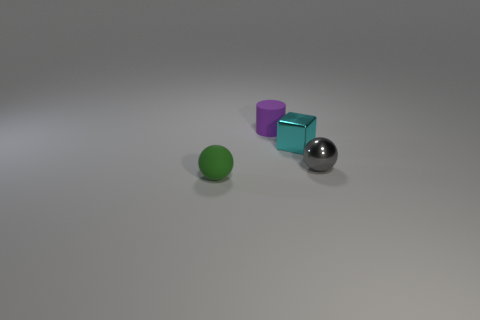Add 1 tiny rubber things. How many objects exist? 5 Subtract all blocks. How many objects are left? 3 Add 4 tiny green spheres. How many tiny green spheres are left? 5 Add 4 tiny cyan rubber things. How many tiny cyan rubber things exist? 4 Subtract 0 blue spheres. How many objects are left? 4 Subtract all brown metallic cylinders. Subtract all tiny purple things. How many objects are left? 3 